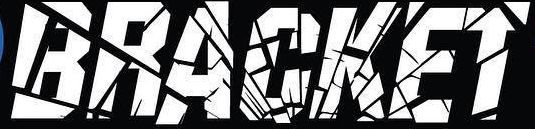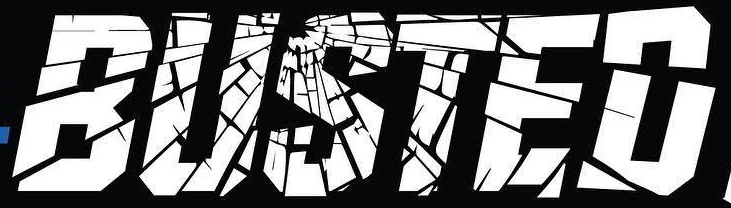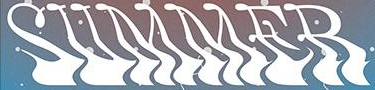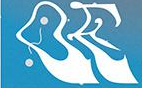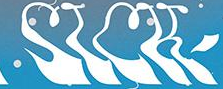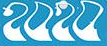What words can you see in these images in sequence, separated by a semicolon? BRACKET; BUSTED; SUMMER; OE; SICK; 2020 